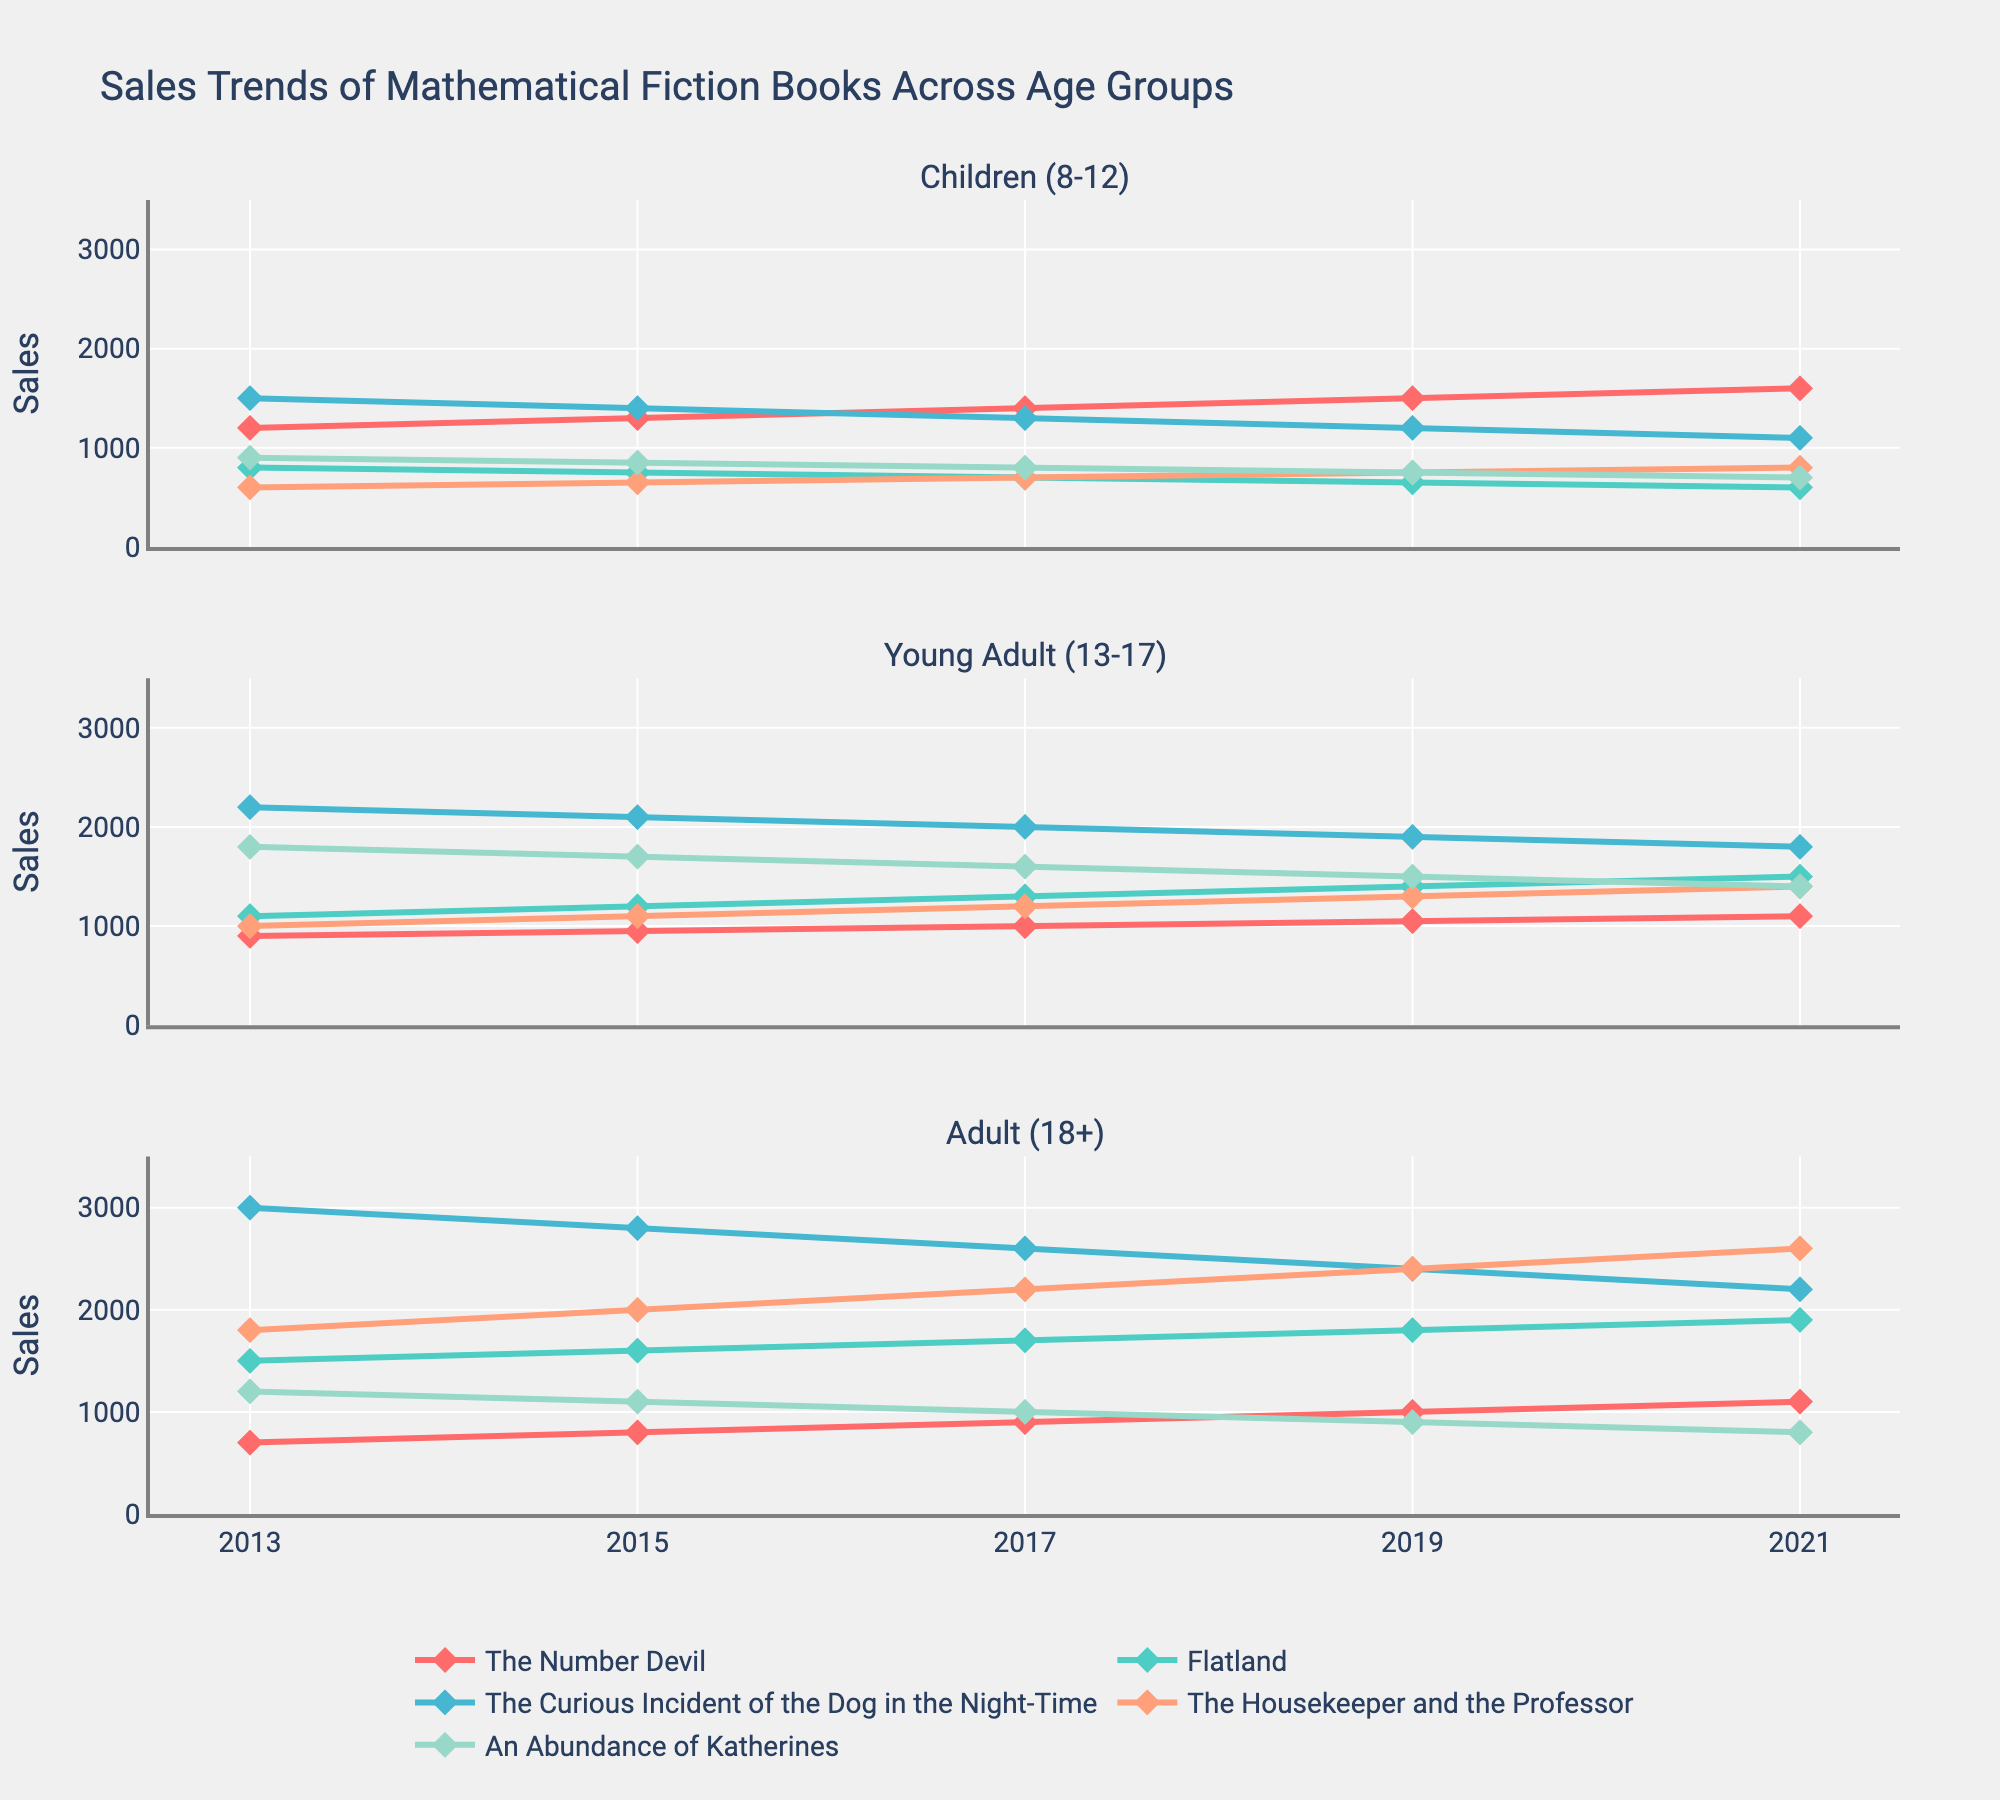What is the title of the figure? The title is typically displayed at the top of the chart and summarizes the main content. The title in the visualization is "Sales Trends of Mathematical Fiction Books Across Age Groups".
Answer: Sales Trends of Mathematical Fiction Books Across Age Groups Which book had the highest sales among Young Adults (13-17) in 2017? To find this, look for the highest point in the 2017 section of the Young Adult row. Following the lines, The Curious Incident of the Dog in the Night-Time shows the highest sales point.
Answer: The Curious Incident of the Dog in the Night-Time How did the sales of "The Number Devil" for Adults (18+) change from 2013 to 2021? Observe the sales points for "The Number Devil" in the Adult row from 2013 to 2021. The sales increased from 700 in 2013 to 1100 in 2021.
Answer: Increased What is the common sales trend for "Flatland" across all age groups? Look at the lines representing "Flatland" across all three rows and observe the changes. "Flatland" generally shows a decreasing trend for each age group as the years progress.
Answer: Decreasing Did "The Housekeeper and the Professor" sell more copies among Children (8-12) or Adults (18+) in 2019? Compare the sales points for both age groups in 2019. Children (8-12) had 750 sales, while Adults (18+) had 2400 sales.
Answer: Adults (18+) What is the overall trend for "An Abundance of Katherines" in the Children (8-12) age group? Observe the sales points for "An Abundance of Katherines" in the Children (8-12) row over the years. The trend shows a continuous decrease from 900 in 2013 to 700 in 2021.
Answer: Decreasing Which book consistently shows an increasing sales trend in the Adult (18+) age group? By tracing the lines for each book in the Adult row, "The Housekeeper and the Professor" shows a consistent increasing trend.
Answer: The Housekeeper and the Professor What was the difference in sales of "The Curious Incident of the Dog in the Night-Time" between Children (8-12) and Young Adults (13-17) in 2013? Check the sales points in 2013 for both age groups and subtract the Children (8-12) sales (1500) from the Young Adult (13-17) sales (2200).
Answer: 700 In which year did "Flatland" have the lowest sales for Young Adults (13-17)? Identify the lowest point on the line representing "Flatland" in the Young Adult row. The lowest sales were in 2013, with 1100 copies sold.
Answer: 2013 